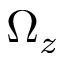<formula> <loc_0><loc_0><loc_500><loc_500>\Omega _ { z }</formula> 